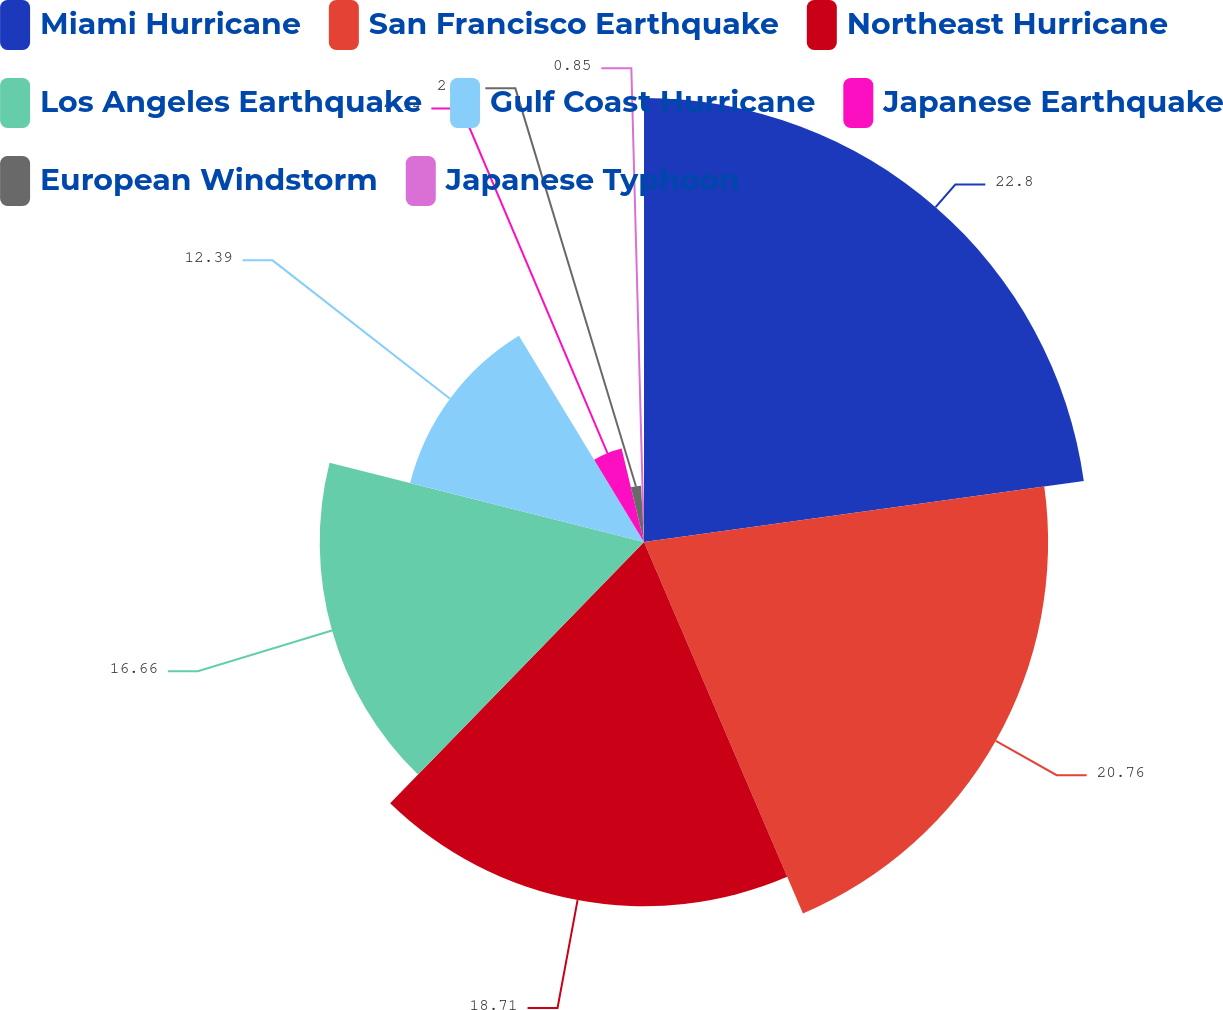Convert chart to OTSL. <chart><loc_0><loc_0><loc_500><loc_500><pie_chart><fcel>Miami Hurricane<fcel>San Francisco Earthquake<fcel>Northeast Hurricane<fcel>Los Angeles Earthquake<fcel>Gulf Coast Hurricane<fcel>Japanese Earthquake<fcel>European Windstorm<fcel>Japanese Typhoon<nl><fcel>22.81%<fcel>20.76%<fcel>18.71%<fcel>16.66%<fcel>12.39%<fcel>4.94%<fcel>2.89%<fcel>0.85%<nl></chart> 